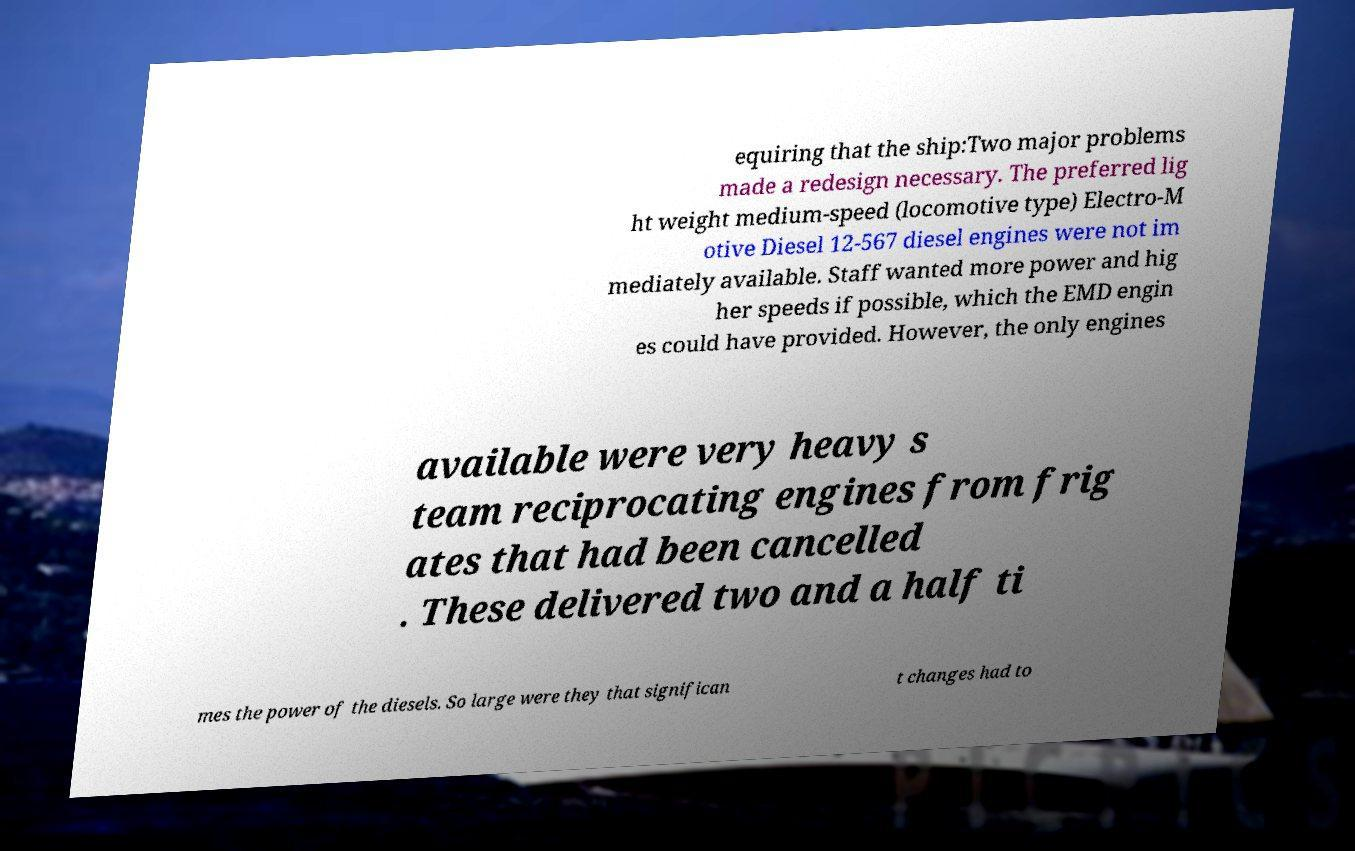Could you extract and type out the text from this image? equiring that the ship:Two major problems made a redesign necessary. The preferred lig ht weight medium-speed (locomotive type) Electro-M otive Diesel 12-567 diesel engines were not im mediately available. Staff wanted more power and hig her speeds if possible, which the EMD engin es could have provided. However, the only engines available were very heavy s team reciprocating engines from frig ates that had been cancelled . These delivered two and a half ti mes the power of the diesels. So large were they that significan t changes had to 